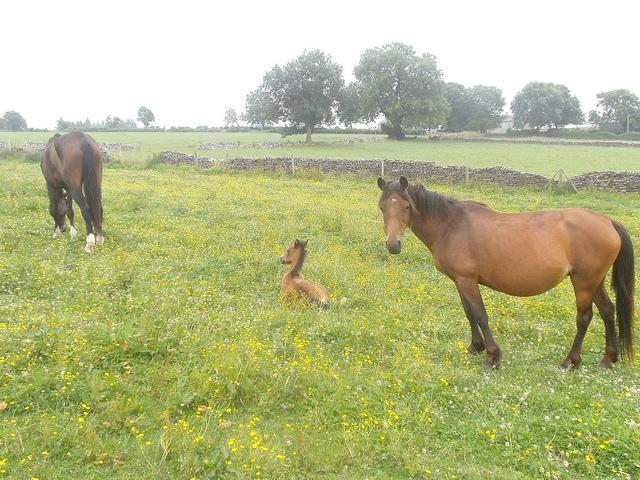How many horses are there?
Give a very brief answer. 3. How many horses are visible?
Give a very brief answer. 2. 